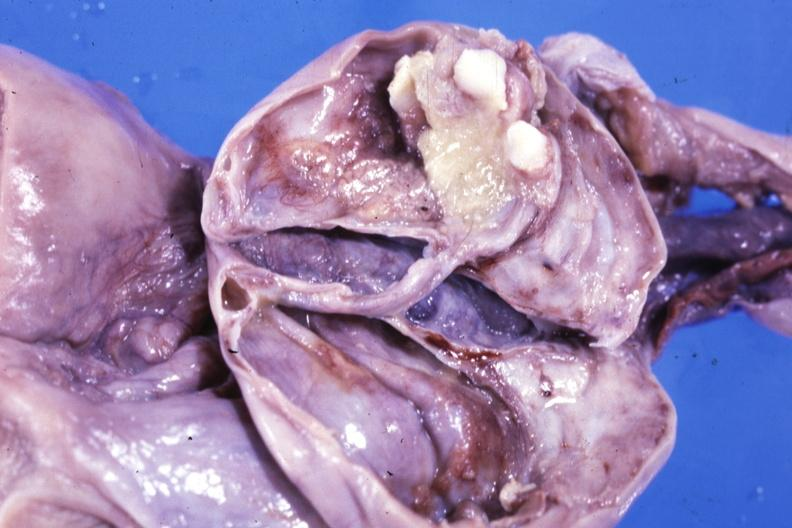s benign cystic teratoma present?
Answer the question using a single word or phrase. Yes 